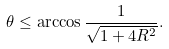Convert formula to latex. <formula><loc_0><loc_0><loc_500><loc_500>\theta \leq \arccos \frac { 1 } { \sqrt { 1 + 4 R ^ { 2 } } } .</formula> 